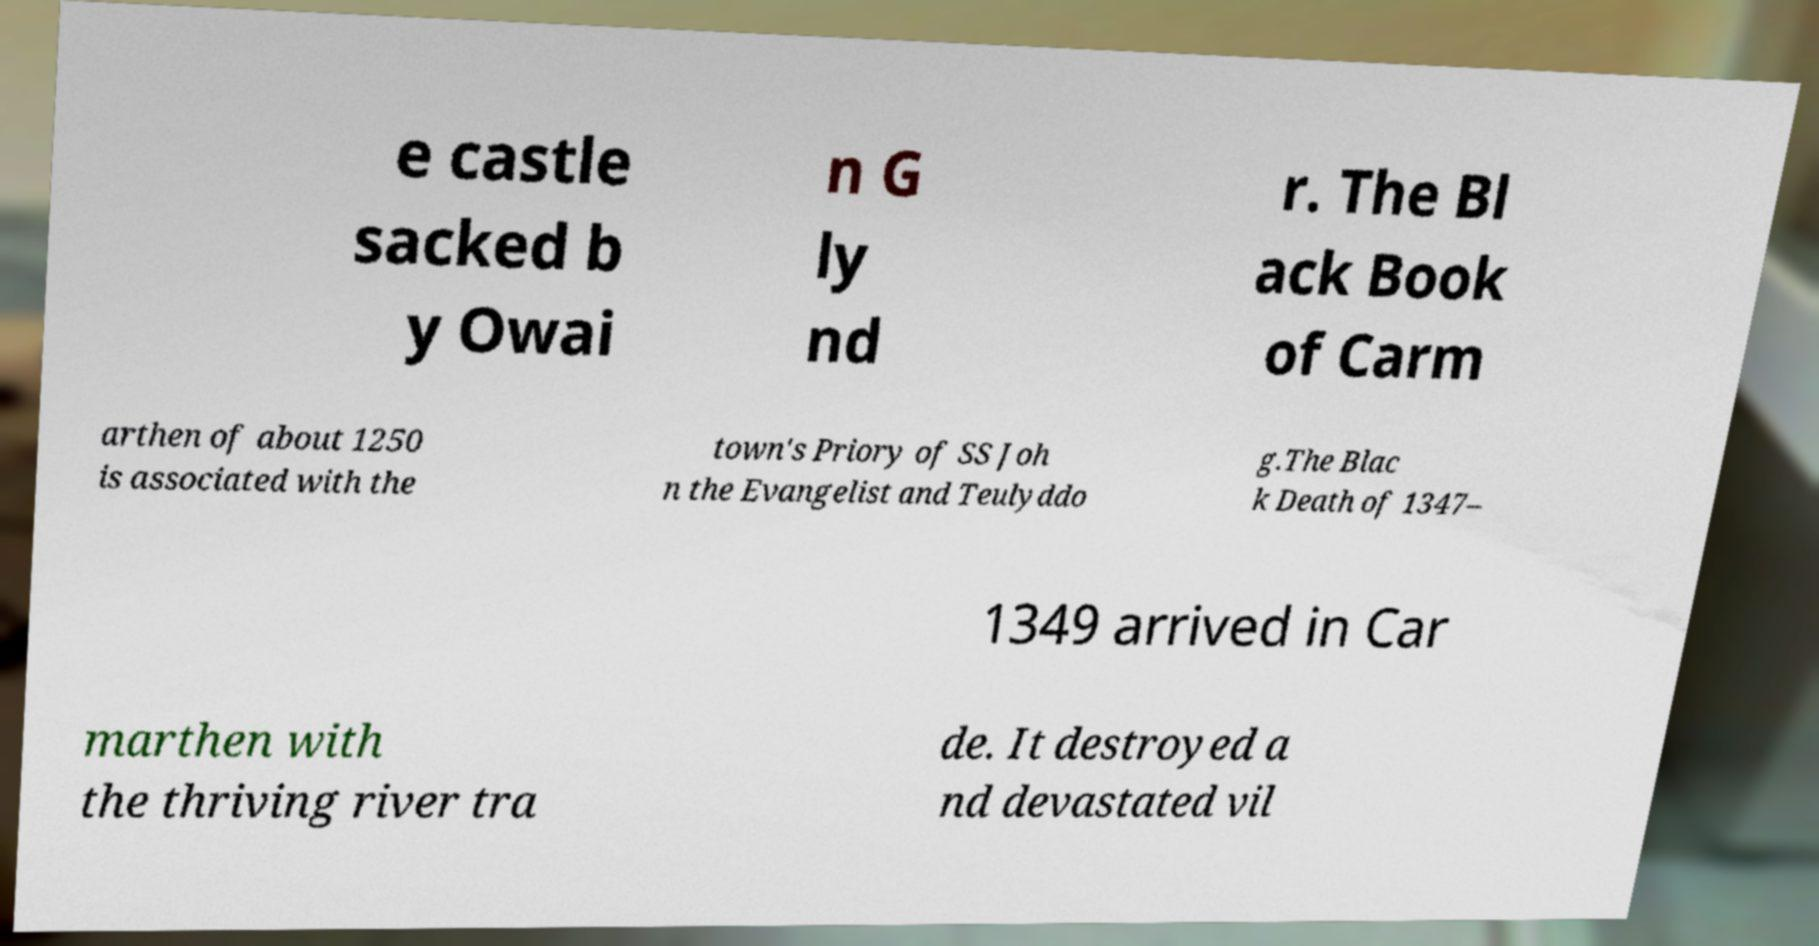I need the written content from this picture converted into text. Can you do that? e castle sacked b y Owai n G ly nd r. The Bl ack Book of Carm arthen of about 1250 is associated with the town's Priory of SS Joh n the Evangelist and Teulyddo g.The Blac k Death of 1347– 1349 arrived in Car marthen with the thriving river tra de. It destroyed a nd devastated vil 